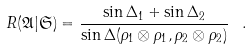<formula> <loc_0><loc_0><loc_500><loc_500>R ( { \mathfrak { A } } | { \mathfrak { S } } ) = \frac { \sin \Delta _ { 1 } + \sin \Delta _ { 2 } } { \sin \Delta ( \rho _ { 1 } \otimes \rho _ { 1 } , \rho _ { 2 } \otimes \rho _ { 2 } ) } \, \ .</formula> 